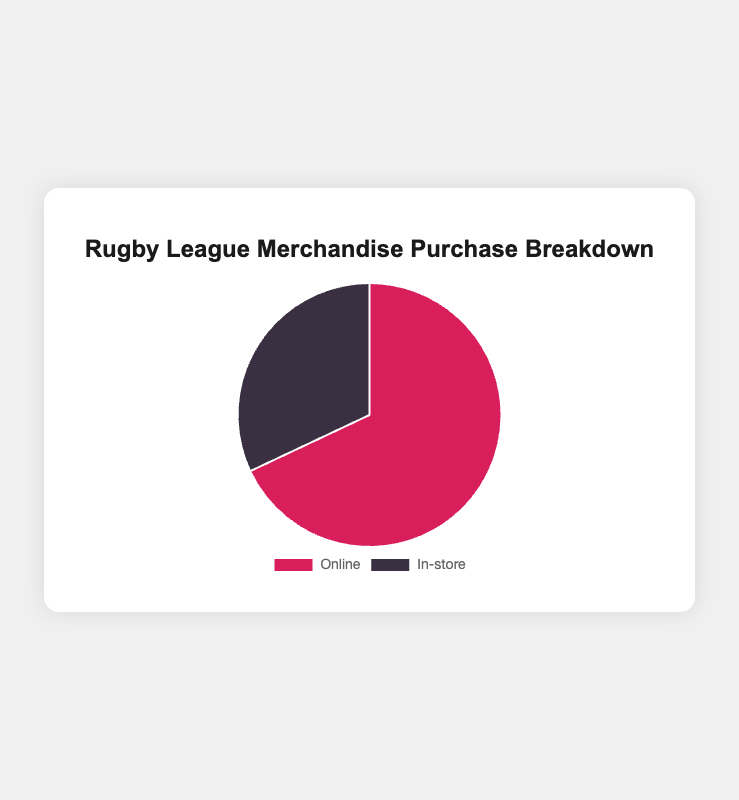Which purchase method is more popular among rugby league fans? The chart shows a breakdown percentage for each method. 68% of fans purchase merchandise online and 32% purchase in-store. Since 68% is greater than 32%, online is more popular.
Answer: Online What percentage of fans purchase merchandise in-store? According to the chart, the portion of fans who buy merchandise in-store is shown in the pie chart and is labeled as 32%.
Answer: 32% How many percentage points more popular is online purchasing compared to in-store? The chart shows 68% for online and 32% for in-store. The difference is 68% - 32%.
Answer: 36 What color represents online purchases in the pie chart? The chart visualizes the data with different colors for each category. Online purchases are represented by the red section of the pie chart.
Answer: Red Which purchasing method has fewer popular stores listed? The descriptions provided show popular stores for each purchasing method. Online has 4 stores listed, whereas in-store has 3 stores. Therefore, in-store has fewer popular stores.
Answer: In-store What is the combined percentage of fans who purchase merchandise either online or in-store? To find the combined percentage, add the percentages of online and in-store purchases: 68% + 32%.
Answer: 100% Which color represents the in-store purchase method? The chart visualizes in-store purchases in a dark color. In this case, it would be the gray section of the pie chart.
Answer: Gray By how much is the percentage of online purchases greater than the percentage required for in-store purchases to reach 50%? Calculate the difference needed for in-store purchases to reach 50%: 50% - 32% = 18%. The percentage of online purchases exceeds this by 68% - 50% = 18%.
Answer: 18 If the percentage of online purchases decreased by 10 percentage points, what would it be? Subtract 10 percentage points from the current percentage of online purchases: 68% - 10%.
Answer: 58% If the total number of fans is 1000, how many fans purchase merchandise in-store? If 32% of 1000 fans purchase merchandise in-store, multiply 1000 by 0.32 (32%): 1000 * 0.32.
Answer: 320 